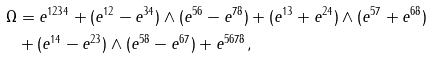Convert formula to latex. <formula><loc_0><loc_0><loc_500><loc_500>\Omega & = e ^ { 1 2 3 4 } + ( e ^ { 1 2 } - e ^ { 3 4 } ) \wedge ( e ^ { 5 6 } - e ^ { 7 8 } ) + ( e ^ { 1 3 } + e ^ { 2 4 } ) \wedge ( e ^ { 5 7 } + e ^ { 6 8 } ) \\ & + ( e ^ { 1 4 } - e ^ { 2 3 } ) \wedge ( e ^ { 5 8 } - e ^ { 6 7 } ) + e ^ { 5 6 7 8 } ,</formula> 